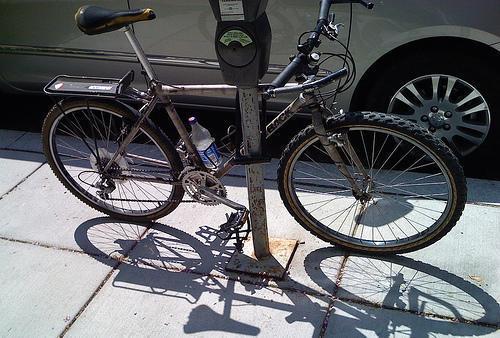How many wheels does bike have?
Give a very brief answer. 2. 